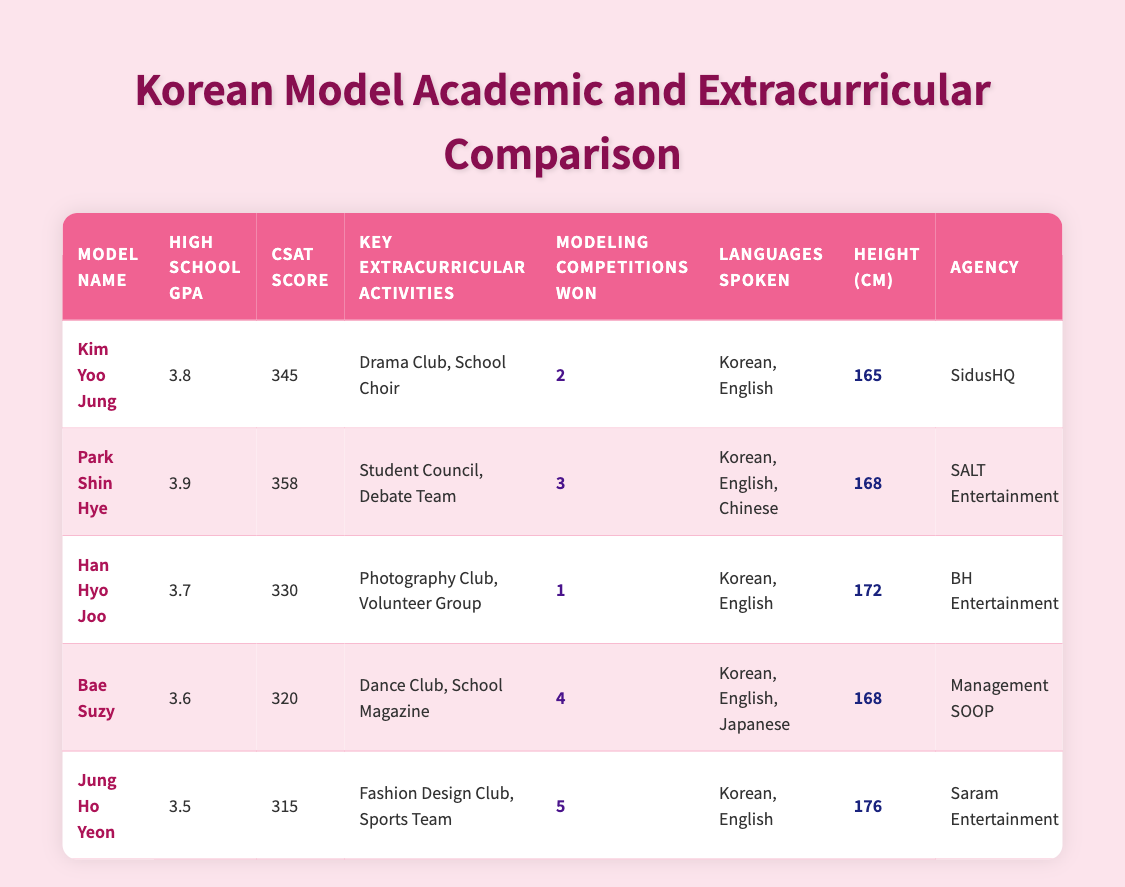What is the highest CSAT score among the models? The CSAT scores for the models are 345, 358, 330, 320, and 315. Among these, 358 is the largest.
Answer: 358 Which model has the lowest GPA? The GPAs are 3.8, 3.9, 3.7, 3.6, and 3.5. The lowest GPA is 3.5.
Answer: 3.5 How many languages does Park Shin Hye speak? Park Shin Hye speaks Korean, English, and Chinese, which totals to 3 languages.
Answer: 3 What is the average height of the models listed? The heights are 165, 168, 172, 168, and 176 cm. The total height is (165 + 168 + 172 + 168 + 176) = 849 cm. Dividing by 5 gives an average height of 169.8 cm.
Answer: 169.8 True or False: Bae Suzy has a higher GPA than Jung Ho Yeon. Bae Suzy's GPA is 3.6, while Jung Ho Yeon's GPA is 3.5. Therefore, Bae Suzy does have a higher GPA than Jung Ho Yeon.
Answer: True Which extracurricular activity is common among the models listed? The common activities can be identified by comparing the extracurricular activities listed for each model: Dance Club, School Magazine, Fashion Design Club, Sports Team, and more. There is no overlap in the activities, showing diversity.
Answer: No common activity How many modeling competitions have Jung Ho Yeon and Bae Suzy won combined? Jung Ho Yeon has won 5 competitions and Bae Suzy has won 4 competitions. Adding them together (5 + 4) gives a total of 9 competitions won.
Answer: 9 What is the height difference between the tallest and shortest model? The tallest model is Jung Ho Yeon at 176 cm, and the shortest is Kim Yoo Jung at 165 cm. The height difference is (176 - 165) = 11 cm.
Answer: 11 cm Which model has the most modeling competitions won? The models have won 2, 3, 1, 4, and 5 competitions. Jung Ho Yeon has won the most with a total of 5 competitions.
Answer: Jung Ho Yeon 